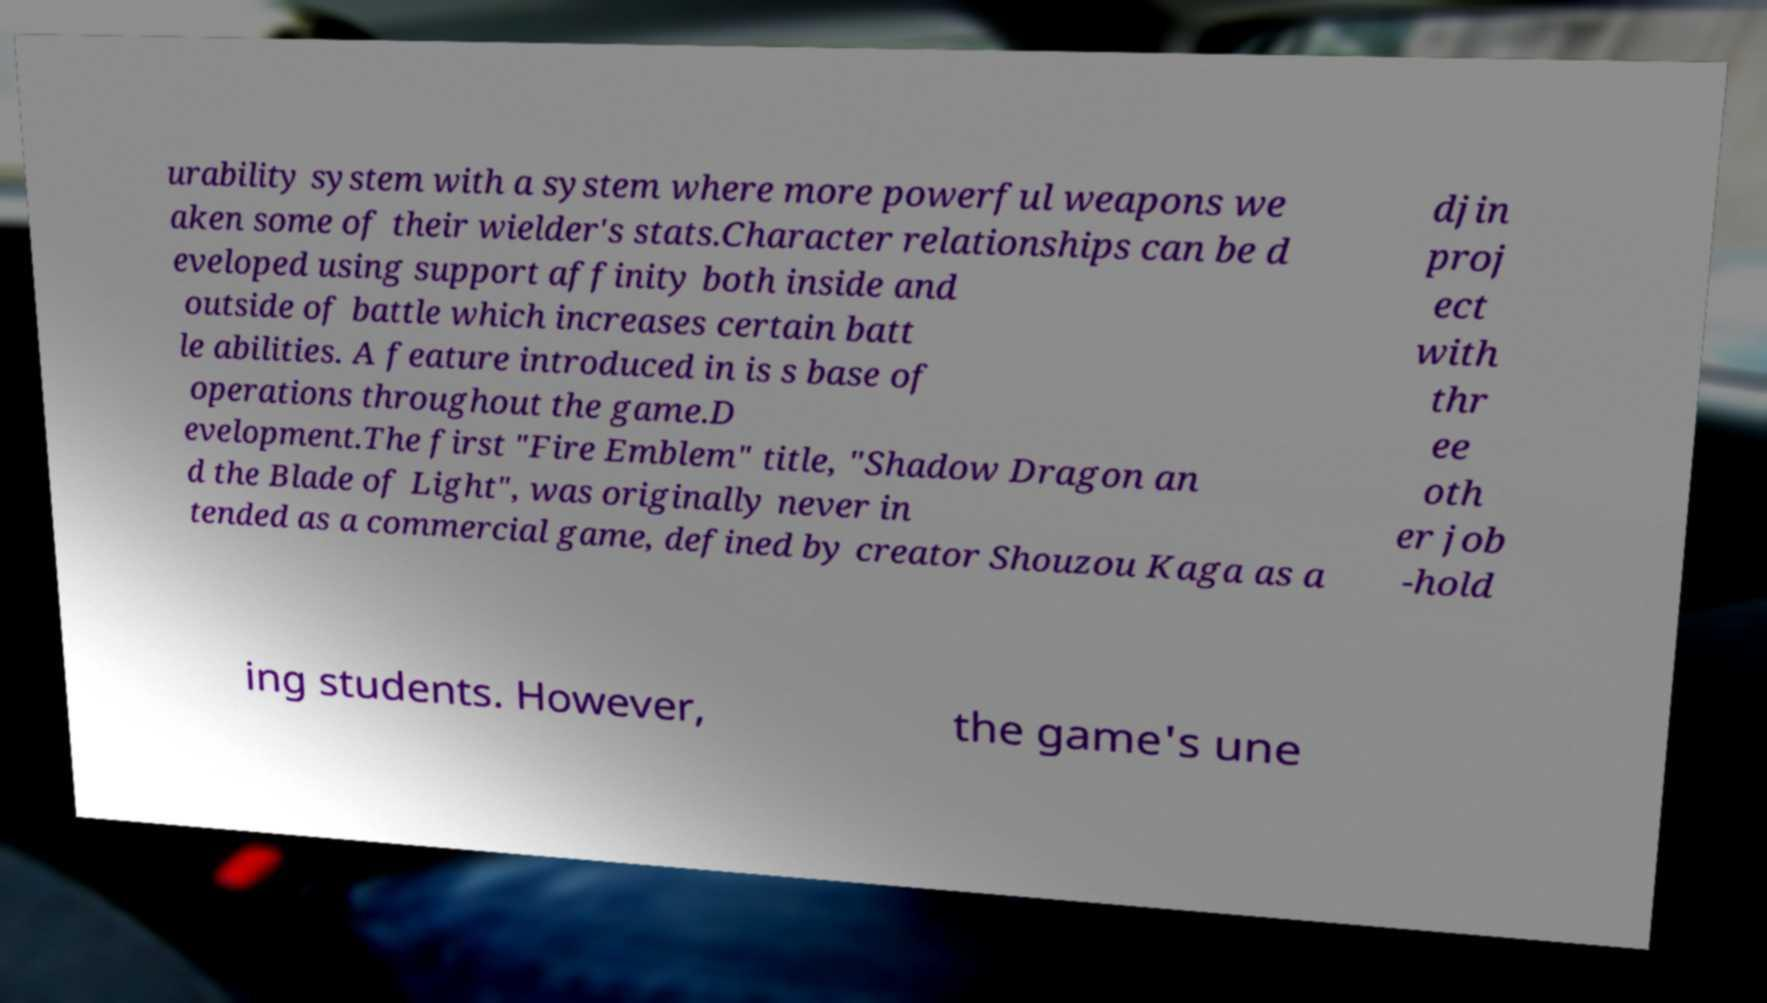For documentation purposes, I need the text within this image transcribed. Could you provide that? urability system with a system where more powerful weapons we aken some of their wielder's stats.Character relationships can be d eveloped using support affinity both inside and outside of battle which increases certain batt le abilities. A feature introduced in is s base of operations throughout the game.D evelopment.The first "Fire Emblem" title, "Shadow Dragon an d the Blade of Light", was originally never in tended as a commercial game, defined by creator Shouzou Kaga as a djin proj ect with thr ee oth er job -hold ing students. However, the game's une 